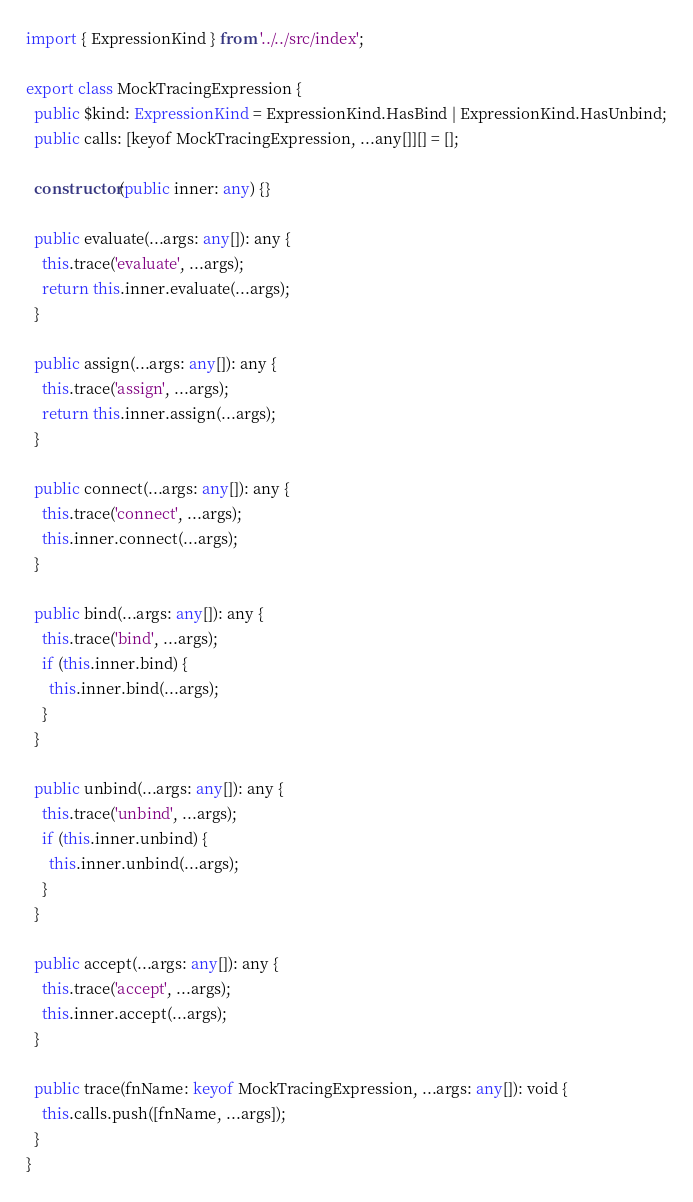<code> <loc_0><loc_0><loc_500><loc_500><_TypeScript_>import { ExpressionKind } from '../../src/index';

export class MockTracingExpression {
  public $kind: ExpressionKind = ExpressionKind.HasBind | ExpressionKind.HasUnbind;
  public calls: [keyof MockTracingExpression, ...any[]][] = [];

  constructor(public inner: any) {}

  public evaluate(...args: any[]): any {
    this.trace('evaluate', ...args);
    return this.inner.evaluate(...args);
  }

  public assign(...args: any[]): any {
    this.trace('assign', ...args);
    return this.inner.assign(...args);
  }

  public connect(...args: any[]): any {
    this.trace('connect', ...args);
    this.inner.connect(...args);
  }

  public bind(...args: any[]): any {
    this.trace('bind', ...args);
    if (this.inner.bind) {
      this.inner.bind(...args);
    }
  }

  public unbind(...args: any[]): any {
    this.trace('unbind', ...args);
    if (this.inner.unbind) {
      this.inner.unbind(...args);
    }
  }

  public accept(...args: any[]): any {
    this.trace('accept', ...args);
    this.inner.accept(...args);
  }

  public trace(fnName: keyof MockTracingExpression, ...args: any[]): void {
    this.calls.push([fnName, ...args]);
  }
}
</code> 